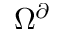Convert formula to latex. <formula><loc_0><loc_0><loc_500><loc_500>\Omega ^ { \partial }</formula> 